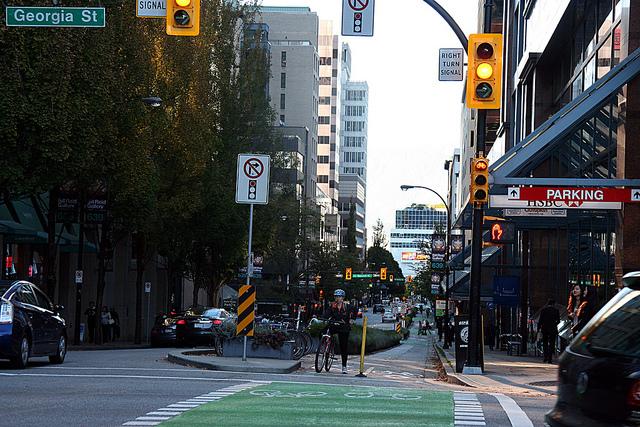How many cyclist are present?
Be succinct. 1. Is this a rural setting?
Be succinct. No. What color is the traffic light?
Short answer required. Yellow. 